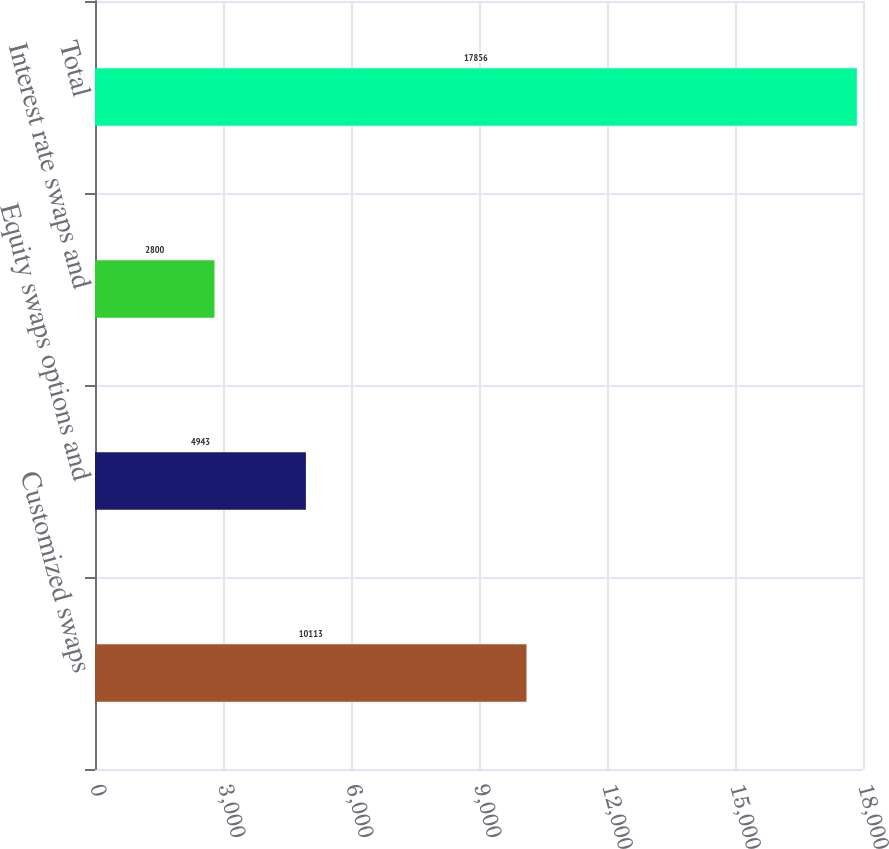Convert chart. <chart><loc_0><loc_0><loc_500><loc_500><bar_chart><fcel>Customized swaps<fcel>Equity swaps options and<fcel>Interest rate swaps and<fcel>Total<nl><fcel>10113<fcel>4943<fcel>2800<fcel>17856<nl></chart> 